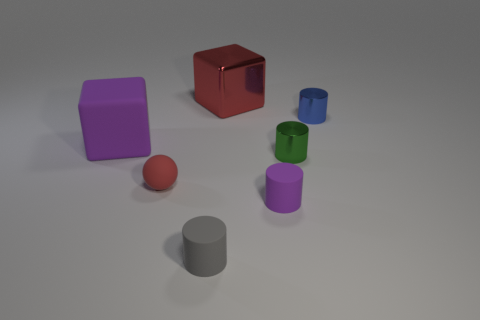There is a big thing that is the same color as the rubber sphere; what shape is it?
Offer a very short reply. Cube. What material is the tiny thing that is the same color as the big shiny cube?
Your response must be concise. Rubber. Is there a shiny object of the same color as the tiny rubber sphere?
Offer a terse response. Yes. What is the material of the large object on the left side of the cube that is behind the small object behind the large matte object?
Keep it short and to the point. Rubber. What size is the thing that is left of the big metal thing and on the right side of the small red sphere?
Your answer should be very brief. Small. How many cubes are tiny blue shiny things or purple objects?
Offer a very short reply. 1. There is a metallic thing that is the same size as the purple matte block; what is its color?
Make the answer very short. Red. Is there anything else that has the same shape as the tiny red matte thing?
Provide a short and direct response. No. What is the color of the other tiny rubber object that is the same shape as the tiny gray thing?
Provide a succinct answer. Purple. What number of things are big cylinders or big cubes on the left side of the red metallic cube?
Give a very brief answer. 1. 